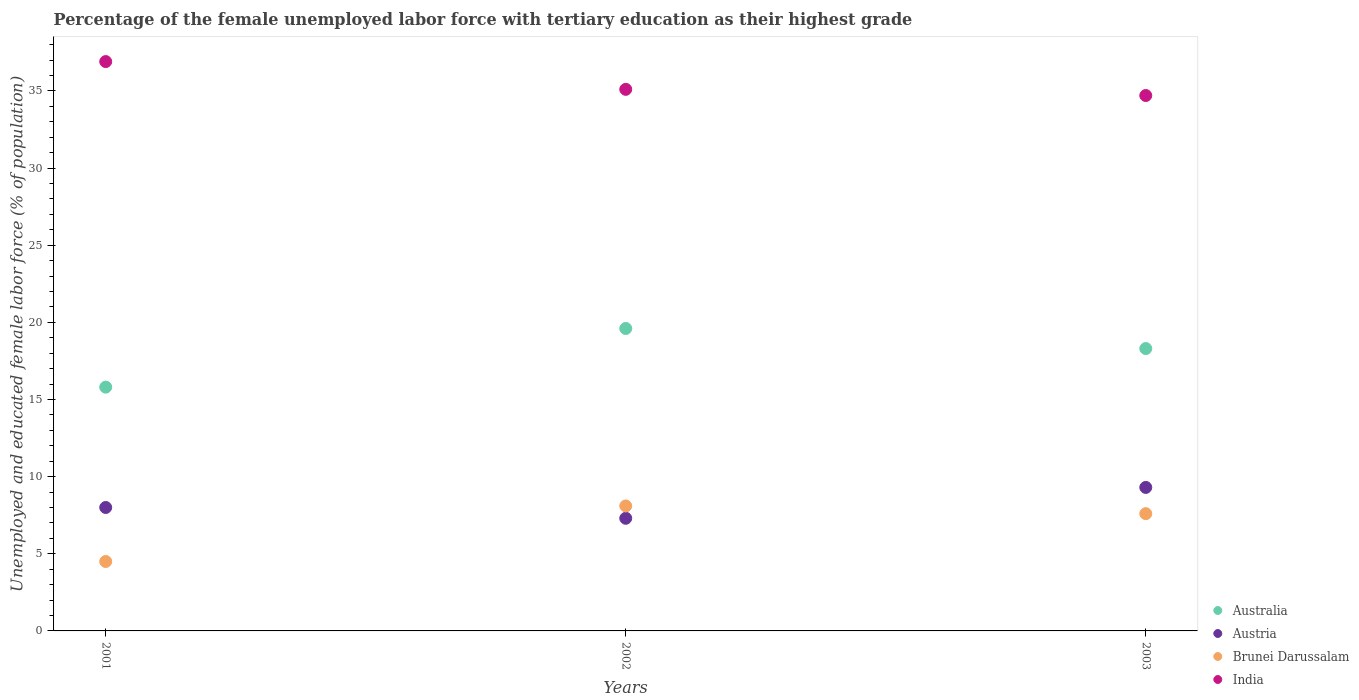How many different coloured dotlines are there?
Your response must be concise. 4. Is the number of dotlines equal to the number of legend labels?
Your response must be concise. Yes. What is the percentage of the unemployed female labor force with tertiary education in Australia in 2003?
Your response must be concise. 18.3. Across all years, what is the maximum percentage of the unemployed female labor force with tertiary education in Austria?
Offer a very short reply. 9.3. In which year was the percentage of the unemployed female labor force with tertiary education in Brunei Darussalam maximum?
Make the answer very short. 2002. In which year was the percentage of the unemployed female labor force with tertiary education in Brunei Darussalam minimum?
Offer a terse response. 2001. What is the total percentage of the unemployed female labor force with tertiary education in India in the graph?
Provide a succinct answer. 106.7. What is the difference between the percentage of the unemployed female labor force with tertiary education in Brunei Darussalam in 2001 and that in 2002?
Offer a very short reply. -3.6. What is the difference between the percentage of the unemployed female labor force with tertiary education in Brunei Darussalam in 2002 and the percentage of the unemployed female labor force with tertiary education in Australia in 2001?
Provide a succinct answer. -7.7. What is the average percentage of the unemployed female labor force with tertiary education in Australia per year?
Your answer should be compact. 17.9. In the year 2003, what is the difference between the percentage of the unemployed female labor force with tertiary education in India and percentage of the unemployed female labor force with tertiary education in Austria?
Provide a short and direct response. 25.4. What is the ratio of the percentage of the unemployed female labor force with tertiary education in India in 2001 to that in 2002?
Make the answer very short. 1.05. Is the difference between the percentage of the unemployed female labor force with tertiary education in India in 2001 and 2002 greater than the difference between the percentage of the unemployed female labor force with tertiary education in Austria in 2001 and 2002?
Offer a very short reply. Yes. What is the difference between the highest and the second highest percentage of the unemployed female labor force with tertiary education in Brunei Darussalam?
Ensure brevity in your answer.  0.5. What is the difference between the highest and the lowest percentage of the unemployed female labor force with tertiary education in Brunei Darussalam?
Your answer should be compact. 3.6. Is it the case that in every year, the sum of the percentage of the unemployed female labor force with tertiary education in Austria and percentage of the unemployed female labor force with tertiary education in Australia  is greater than the sum of percentage of the unemployed female labor force with tertiary education in India and percentage of the unemployed female labor force with tertiary education in Brunei Darussalam?
Your answer should be very brief. Yes. Is it the case that in every year, the sum of the percentage of the unemployed female labor force with tertiary education in Brunei Darussalam and percentage of the unemployed female labor force with tertiary education in India  is greater than the percentage of the unemployed female labor force with tertiary education in Australia?
Give a very brief answer. Yes. Does the percentage of the unemployed female labor force with tertiary education in Australia monotonically increase over the years?
Offer a terse response. No. Is the percentage of the unemployed female labor force with tertiary education in India strictly less than the percentage of the unemployed female labor force with tertiary education in Australia over the years?
Offer a very short reply. No. How many dotlines are there?
Make the answer very short. 4. How many years are there in the graph?
Make the answer very short. 3. Does the graph contain grids?
Ensure brevity in your answer.  No. Where does the legend appear in the graph?
Provide a succinct answer. Bottom right. How many legend labels are there?
Your response must be concise. 4. How are the legend labels stacked?
Make the answer very short. Vertical. What is the title of the graph?
Provide a short and direct response. Percentage of the female unemployed labor force with tertiary education as their highest grade. Does "Mozambique" appear as one of the legend labels in the graph?
Offer a terse response. No. What is the label or title of the X-axis?
Offer a very short reply. Years. What is the label or title of the Y-axis?
Give a very brief answer. Unemployed and educated female labor force (% of population). What is the Unemployed and educated female labor force (% of population) of Australia in 2001?
Your response must be concise. 15.8. What is the Unemployed and educated female labor force (% of population) of Austria in 2001?
Provide a short and direct response. 8. What is the Unemployed and educated female labor force (% of population) of India in 2001?
Your answer should be compact. 36.9. What is the Unemployed and educated female labor force (% of population) in Australia in 2002?
Keep it short and to the point. 19.6. What is the Unemployed and educated female labor force (% of population) of Austria in 2002?
Give a very brief answer. 7.3. What is the Unemployed and educated female labor force (% of population) in Brunei Darussalam in 2002?
Keep it short and to the point. 8.1. What is the Unemployed and educated female labor force (% of population) in India in 2002?
Keep it short and to the point. 35.1. What is the Unemployed and educated female labor force (% of population) of Australia in 2003?
Provide a short and direct response. 18.3. What is the Unemployed and educated female labor force (% of population) in Austria in 2003?
Provide a succinct answer. 9.3. What is the Unemployed and educated female labor force (% of population) in Brunei Darussalam in 2003?
Your answer should be compact. 7.6. What is the Unemployed and educated female labor force (% of population) of India in 2003?
Provide a succinct answer. 34.7. Across all years, what is the maximum Unemployed and educated female labor force (% of population) of Australia?
Provide a succinct answer. 19.6. Across all years, what is the maximum Unemployed and educated female labor force (% of population) in Austria?
Provide a succinct answer. 9.3. Across all years, what is the maximum Unemployed and educated female labor force (% of population) of Brunei Darussalam?
Your response must be concise. 8.1. Across all years, what is the maximum Unemployed and educated female labor force (% of population) in India?
Your response must be concise. 36.9. Across all years, what is the minimum Unemployed and educated female labor force (% of population) of Australia?
Offer a terse response. 15.8. Across all years, what is the minimum Unemployed and educated female labor force (% of population) of Austria?
Make the answer very short. 7.3. Across all years, what is the minimum Unemployed and educated female labor force (% of population) of India?
Provide a succinct answer. 34.7. What is the total Unemployed and educated female labor force (% of population) of Australia in the graph?
Your answer should be very brief. 53.7. What is the total Unemployed and educated female labor force (% of population) in Austria in the graph?
Offer a very short reply. 24.6. What is the total Unemployed and educated female labor force (% of population) of Brunei Darussalam in the graph?
Provide a succinct answer. 20.2. What is the total Unemployed and educated female labor force (% of population) in India in the graph?
Ensure brevity in your answer.  106.7. What is the difference between the Unemployed and educated female labor force (% of population) of Australia in 2001 and that in 2003?
Keep it short and to the point. -2.5. What is the difference between the Unemployed and educated female labor force (% of population) in India in 2001 and that in 2003?
Offer a terse response. 2.2. What is the difference between the Unemployed and educated female labor force (% of population) in Australia in 2002 and that in 2003?
Provide a succinct answer. 1.3. What is the difference between the Unemployed and educated female labor force (% of population) in Austria in 2002 and that in 2003?
Your response must be concise. -2. What is the difference between the Unemployed and educated female labor force (% of population) of Brunei Darussalam in 2002 and that in 2003?
Offer a very short reply. 0.5. What is the difference between the Unemployed and educated female labor force (% of population) in Australia in 2001 and the Unemployed and educated female labor force (% of population) in Austria in 2002?
Offer a terse response. 8.5. What is the difference between the Unemployed and educated female labor force (% of population) in Australia in 2001 and the Unemployed and educated female labor force (% of population) in India in 2002?
Your answer should be compact. -19.3. What is the difference between the Unemployed and educated female labor force (% of population) of Austria in 2001 and the Unemployed and educated female labor force (% of population) of Brunei Darussalam in 2002?
Your response must be concise. -0.1. What is the difference between the Unemployed and educated female labor force (% of population) in Austria in 2001 and the Unemployed and educated female labor force (% of population) in India in 2002?
Give a very brief answer. -27.1. What is the difference between the Unemployed and educated female labor force (% of population) in Brunei Darussalam in 2001 and the Unemployed and educated female labor force (% of population) in India in 2002?
Keep it short and to the point. -30.6. What is the difference between the Unemployed and educated female labor force (% of population) of Australia in 2001 and the Unemployed and educated female labor force (% of population) of Austria in 2003?
Your answer should be very brief. 6.5. What is the difference between the Unemployed and educated female labor force (% of population) of Australia in 2001 and the Unemployed and educated female labor force (% of population) of Brunei Darussalam in 2003?
Make the answer very short. 8.2. What is the difference between the Unemployed and educated female labor force (% of population) in Australia in 2001 and the Unemployed and educated female labor force (% of population) in India in 2003?
Your response must be concise. -18.9. What is the difference between the Unemployed and educated female labor force (% of population) of Austria in 2001 and the Unemployed and educated female labor force (% of population) of India in 2003?
Offer a terse response. -26.7. What is the difference between the Unemployed and educated female labor force (% of population) of Brunei Darussalam in 2001 and the Unemployed and educated female labor force (% of population) of India in 2003?
Your answer should be compact. -30.2. What is the difference between the Unemployed and educated female labor force (% of population) in Australia in 2002 and the Unemployed and educated female labor force (% of population) in India in 2003?
Your response must be concise. -15.1. What is the difference between the Unemployed and educated female labor force (% of population) in Austria in 2002 and the Unemployed and educated female labor force (% of population) in India in 2003?
Your response must be concise. -27.4. What is the difference between the Unemployed and educated female labor force (% of population) of Brunei Darussalam in 2002 and the Unemployed and educated female labor force (% of population) of India in 2003?
Make the answer very short. -26.6. What is the average Unemployed and educated female labor force (% of population) in Austria per year?
Keep it short and to the point. 8.2. What is the average Unemployed and educated female labor force (% of population) in Brunei Darussalam per year?
Keep it short and to the point. 6.73. What is the average Unemployed and educated female labor force (% of population) of India per year?
Make the answer very short. 35.57. In the year 2001, what is the difference between the Unemployed and educated female labor force (% of population) in Australia and Unemployed and educated female labor force (% of population) in Brunei Darussalam?
Offer a terse response. 11.3. In the year 2001, what is the difference between the Unemployed and educated female labor force (% of population) in Australia and Unemployed and educated female labor force (% of population) in India?
Your answer should be compact. -21.1. In the year 2001, what is the difference between the Unemployed and educated female labor force (% of population) in Austria and Unemployed and educated female labor force (% of population) in Brunei Darussalam?
Your response must be concise. 3.5. In the year 2001, what is the difference between the Unemployed and educated female labor force (% of population) of Austria and Unemployed and educated female labor force (% of population) of India?
Provide a succinct answer. -28.9. In the year 2001, what is the difference between the Unemployed and educated female labor force (% of population) of Brunei Darussalam and Unemployed and educated female labor force (% of population) of India?
Make the answer very short. -32.4. In the year 2002, what is the difference between the Unemployed and educated female labor force (% of population) of Australia and Unemployed and educated female labor force (% of population) of Brunei Darussalam?
Make the answer very short. 11.5. In the year 2002, what is the difference between the Unemployed and educated female labor force (% of population) of Australia and Unemployed and educated female labor force (% of population) of India?
Provide a short and direct response. -15.5. In the year 2002, what is the difference between the Unemployed and educated female labor force (% of population) of Austria and Unemployed and educated female labor force (% of population) of Brunei Darussalam?
Your answer should be compact. -0.8. In the year 2002, what is the difference between the Unemployed and educated female labor force (% of population) of Austria and Unemployed and educated female labor force (% of population) of India?
Your response must be concise. -27.8. In the year 2003, what is the difference between the Unemployed and educated female labor force (% of population) of Australia and Unemployed and educated female labor force (% of population) of Austria?
Ensure brevity in your answer.  9. In the year 2003, what is the difference between the Unemployed and educated female labor force (% of population) in Australia and Unemployed and educated female labor force (% of population) in Brunei Darussalam?
Ensure brevity in your answer.  10.7. In the year 2003, what is the difference between the Unemployed and educated female labor force (% of population) of Australia and Unemployed and educated female labor force (% of population) of India?
Make the answer very short. -16.4. In the year 2003, what is the difference between the Unemployed and educated female labor force (% of population) in Austria and Unemployed and educated female labor force (% of population) in India?
Your answer should be compact. -25.4. In the year 2003, what is the difference between the Unemployed and educated female labor force (% of population) of Brunei Darussalam and Unemployed and educated female labor force (% of population) of India?
Offer a very short reply. -27.1. What is the ratio of the Unemployed and educated female labor force (% of population) of Australia in 2001 to that in 2002?
Your response must be concise. 0.81. What is the ratio of the Unemployed and educated female labor force (% of population) of Austria in 2001 to that in 2002?
Keep it short and to the point. 1.1. What is the ratio of the Unemployed and educated female labor force (% of population) of Brunei Darussalam in 2001 to that in 2002?
Your answer should be compact. 0.56. What is the ratio of the Unemployed and educated female labor force (% of population) of India in 2001 to that in 2002?
Your response must be concise. 1.05. What is the ratio of the Unemployed and educated female labor force (% of population) in Australia in 2001 to that in 2003?
Provide a short and direct response. 0.86. What is the ratio of the Unemployed and educated female labor force (% of population) in Austria in 2001 to that in 2003?
Make the answer very short. 0.86. What is the ratio of the Unemployed and educated female labor force (% of population) in Brunei Darussalam in 2001 to that in 2003?
Give a very brief answer. 0.59. What is the ratio of the Unemployed and educated female labor force (% of population) of India in 2001 to that in 2003?
Provide a succinct answer. 1.06. What is the ratio of the Unemployed and educated female labor force (% of population) of Australia in 2002 to that in 2003?
Your answer should be compact. 1.07. What is the ratio of the Unemployed and educated female labor force (% of population) of Austria in 2002 to that in 2003?
Your response must be concise. 0.78. What is the ratio of the Unemployed and educated female labor force (% of population) of Brunei Darussalam in 2002 to that in 2003?
Provide a short and direct response. 1.07. What is the ratio of the Unemployed and educated female labor force (% of population) in India in 2002 to that in 2003?
Keep it short and to the point. 1.01. What is the difference between the highest and the second highest Unemployed and educated female labor force (% of population) of Austria?
Offer a terse response. 1.3. What is the difference between the highest and the second highest Unemployed and educated female labor force (% of population) in Brunei Darussalam?
Your response must be concise. 0.5. What is the difference between the highest and the lowest Unemployed and educated female labor force (% of population) in Australia?
Ensure brevity in your answer.  3.8. What is the difference between the highest and the lowest Unemployed and educated female labor force (% of population) of Austria?
Provide a short and direct response. 2. 